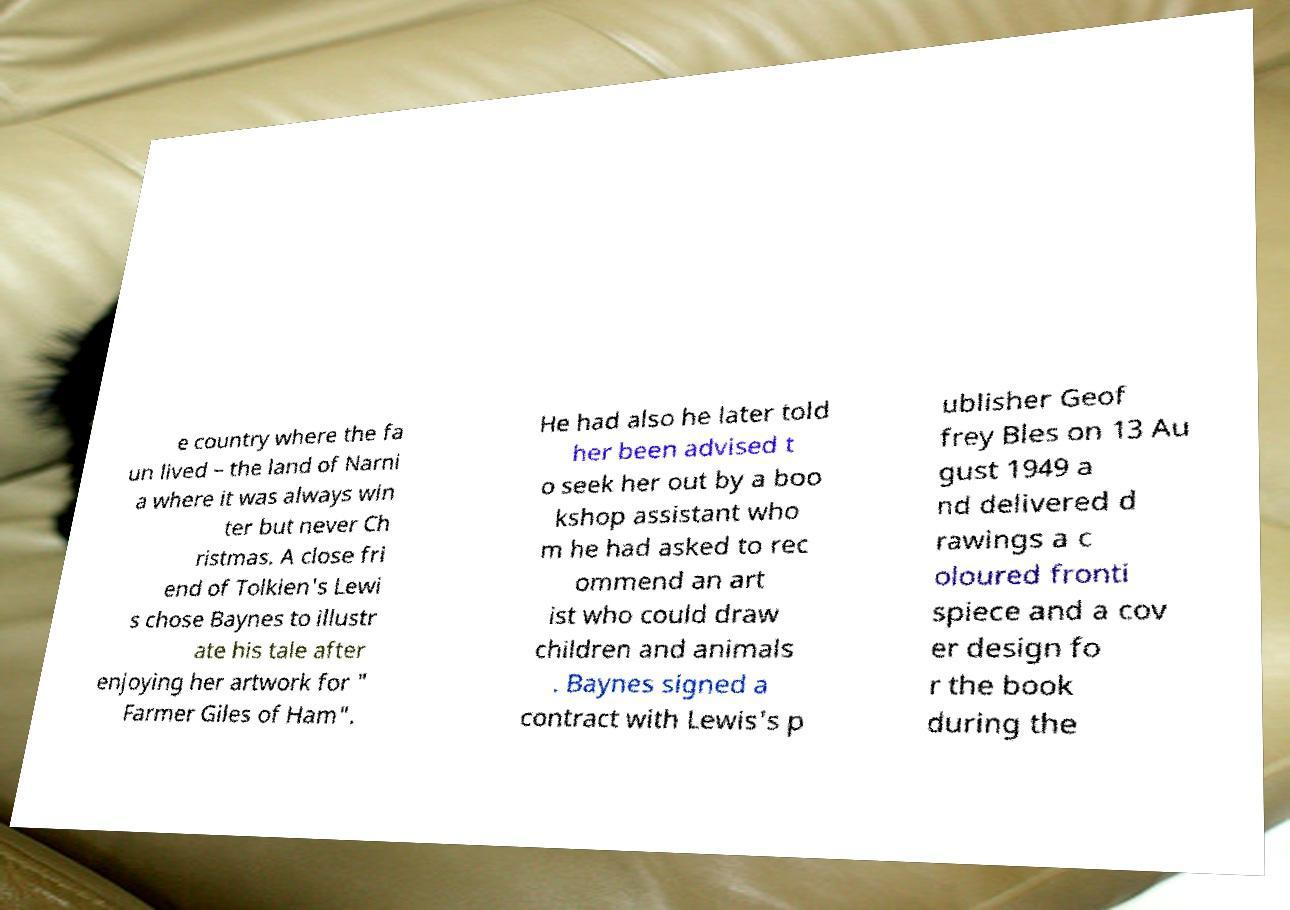What messages or text are displayed in this image? I need them in a readable, typed format. e country where the fa un lived – the land of Narni a where it was always win ter but never Ch ristmas. A close fri end of Tolkien's Lewi s chose Baynes to illustr ate his tale after enjoying her artwork for " Farmer Giles of Ham". He had also he later told her been advised t o seek her out by a boo kshop assistant who m he had asked to rec ommend an art ist who could draw children and animals . Baynes signed a contract with Lewis's p ublisher Geof frey Bles on 13 Au gust 1949 a nd delivered d rawings a c oloured fronti spiece and a cov er design fo r the book during the 